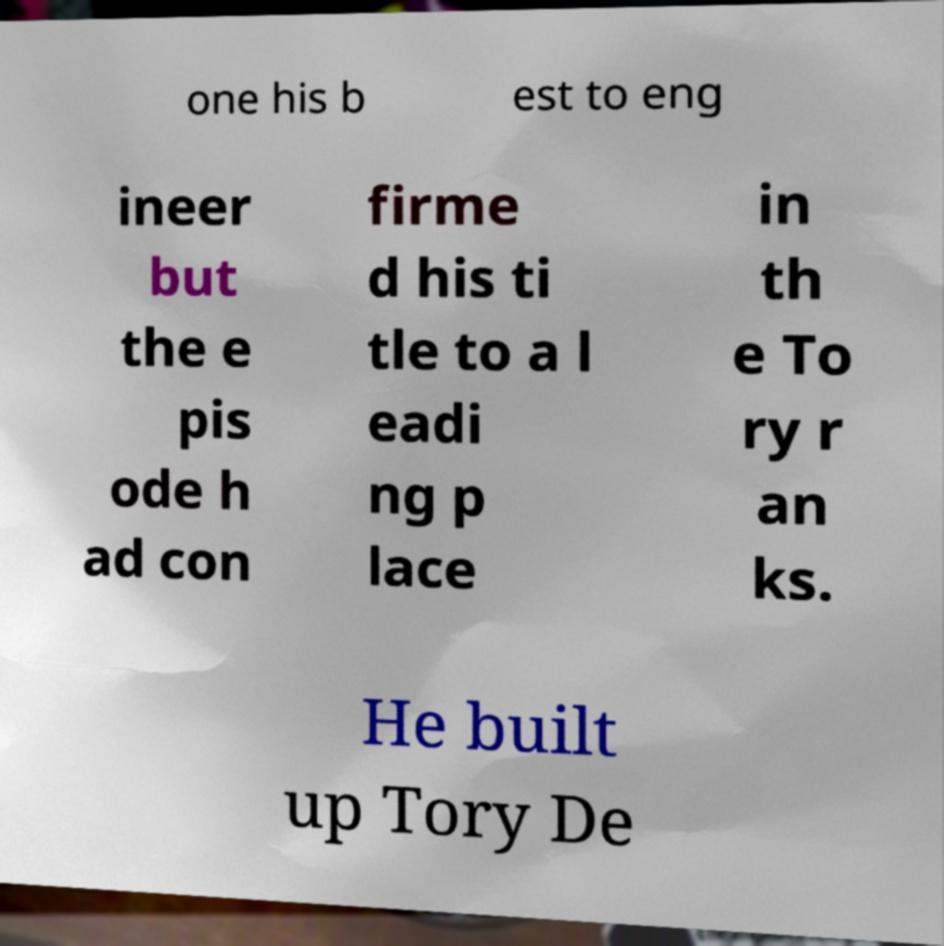Could you assist in decoding the text presented in this image and type it out clearly? one his b est to eng ineer but the e pis ode h ad con firme d his ti tle to a l eadi ng p lace in th e To ry r an ks. He built up Tory De 